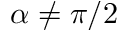Convert formula to latex. <formula><loc_0><loc_0><loc_500><loc_500>\alpha \neq \pi / 2</formula> 